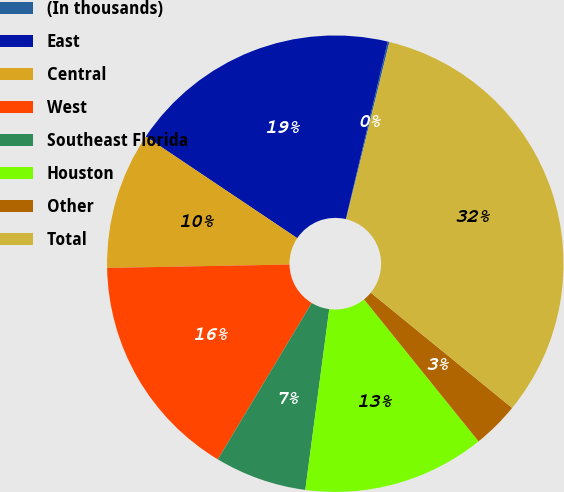Convert chart to OTSL. <chart><loc_0><loc_0><loc_500><loc_500><pie_chart><fcel>(In thousands)<fcel>East<fcel>Central<fcel>West<fcel>Southeast Florida<fcel>Houston<fcel>Other<fcel>Total<nl><fcel>0.12%<fcel>19.29%<fcel>9.7%<fcel>16.1%<fcel>6.51%<fcel>12.9%<fcel>3.31%<fcel>32.08%<nl></chart> 